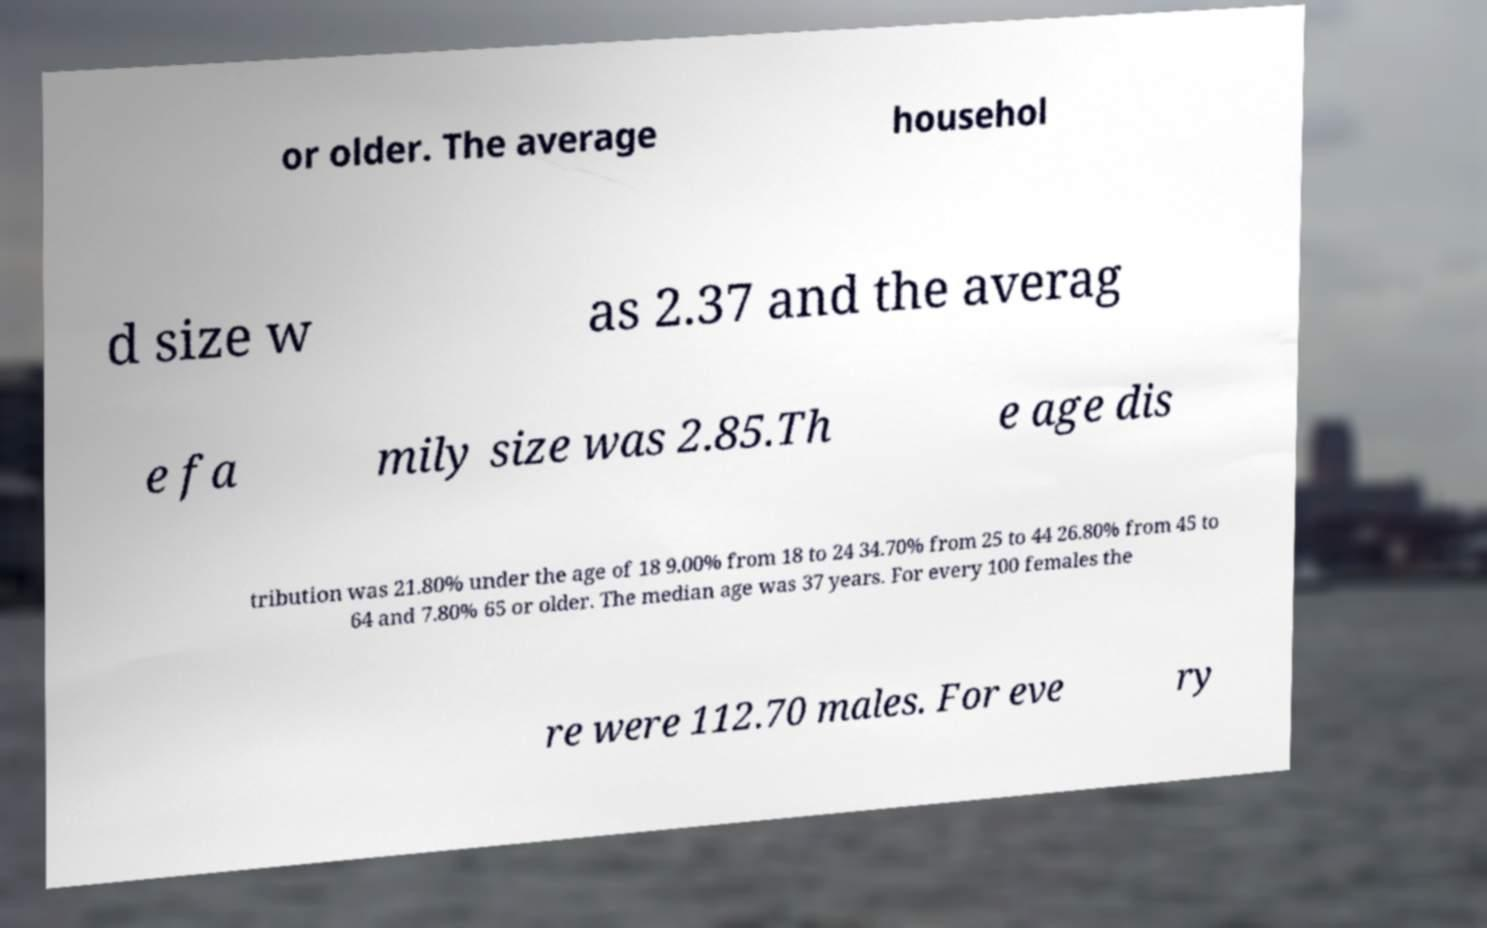Can you accurately transcribe the text from the provided image for me? or older. The average househol d size w as 2.37 and the averag e fa mily size was 2.85.Th e age dis tribution was 21.80% under the age of 18 9.00% from 18 to 24 34.70% from 25 to 44 26.80% from 45 to 64 and 7.80% 65 or older. The median age was 37 years. For every 100 females the re were 112.70 males. For eve ry 